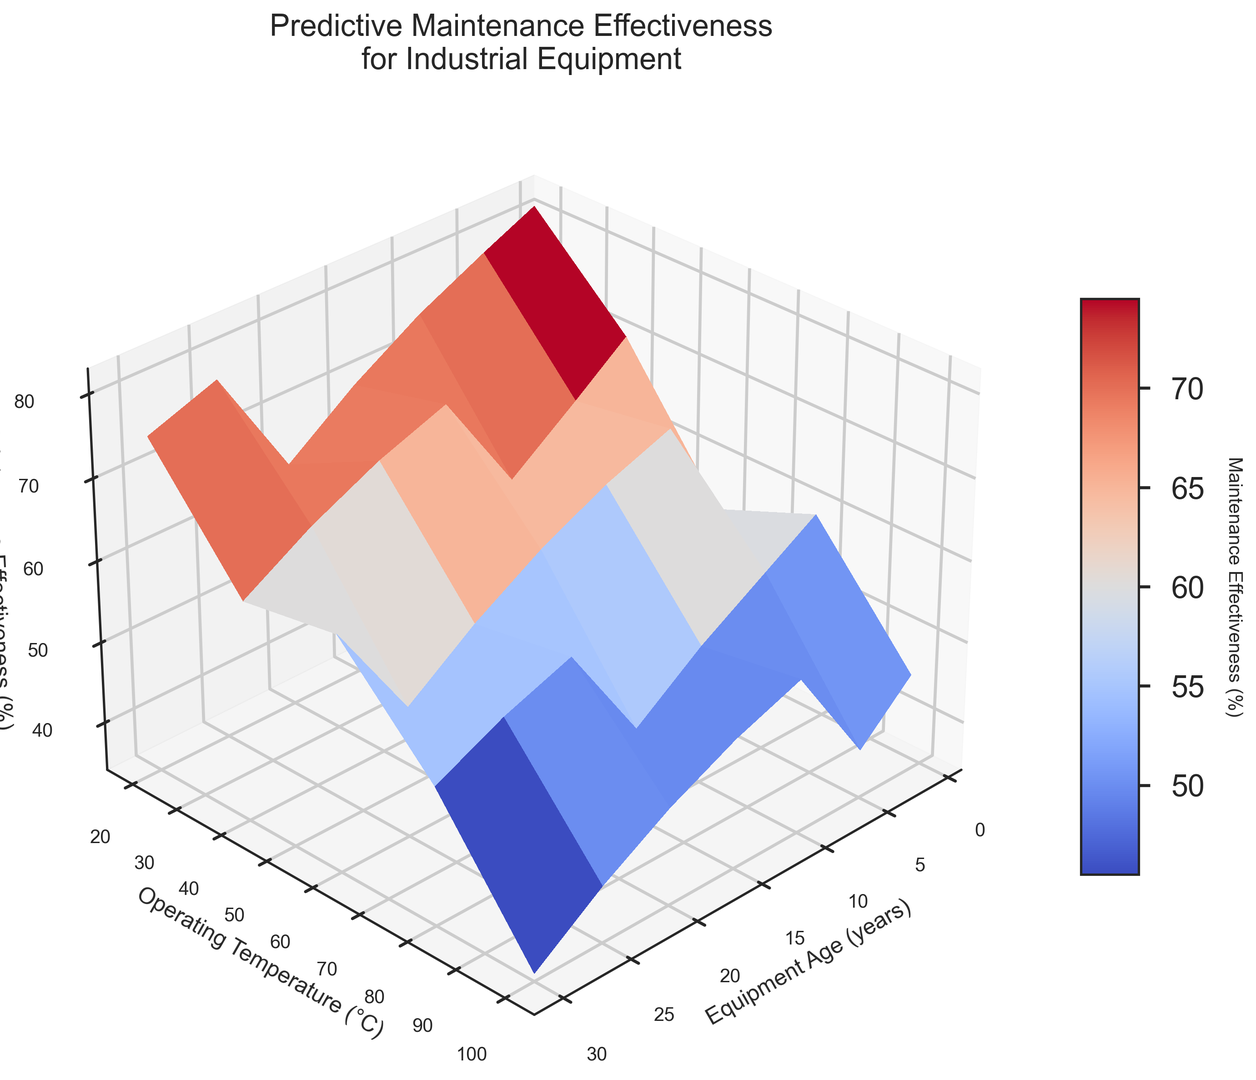What is the maintenance effectiveness for equipment aged 10 years at an operating temperature of 60°C? First, identify where the equipment age is 10 years and the operating temperature is 60°C on the X and Y axes, respectively. Then look at the corresponding Z value, which represents maintenance effectiveness.
Answer: 66% Does maintenance effectiveness generally increase or decrease as equipment age increases for a given operating temperature? Observe the trend of the Z values as you move along the X axis for any fixed Y value. As equipment age increases, the Z values (maintenance effectiveness) generally decrease.
Answer: Decrease Which operating temperature gives the highest maintenance effectiveness for equipment aged 5 years? Locate the curve for equipment aged 5 years. Check the Z values along this curve and identify the highest value, along with its corresponding Y value.
Answer: 20°C Compare the maintenance effectiveness of equipment aged 1 year at 80°C and 10 years at 40°C. Find the maintenance effectiveness at 80°C for 1-year-old equipment (look for Y=80°C, X=1 year). Similarly, find the effectiveness at 40°C for 10-year-old equipment. Compare these two Z values.
Answer: 70% and 70% What trend is observable in maintenance effectiveness as the operating temperature increases for equipment aged 20 years? Follow the Z values for the curve where X is 20 years as Y increases. Notice that the effectiveness values consistently decrease.
Answer: Decrease What is the average maintenance effectiveness for equipment aged 15 years? Locate all Z values corresponding to the X value of 15 years: 68, 65, 61, 56, and 50. Sum these values and divide by the number of points (5). (68+65+61+56+50)/5 = 60.
Answer: 60 For equipment aged 25 years, which operating temperature has the lowest maintenance effectiveness? Identify the curve for X = 25 years and look for the lowest Z value along this curve, noting the corresponding Y value.
Answer: 100°C Compare the maintenance effectiveness at 20°C for equipment aged 1 year and 30 years. Find the Z values at Y = 20°C for X = 1 year and X = 30 years. Compare these two effectiveness values.
Answer: 82% and 53% What pattern do you observe in maintenance effectiveness as both equipment age and operating temperature increase? By observing the general surface trend, it is clear that as both X and Y increase, the Z values decrease, indicating a combined negative effect of age and higher temperature on maintenance effectiveness.
Answer: Decrease What is the decrease in maintenance effectiveness when the operating temperature increases from 40°C to 80°C for 5-year-old equipment? Find the Z values at 40°C and 80°C for X = 5 years, which are 75 and 66, respectively. Compute the difference 75 - 66.
Answer: 9 